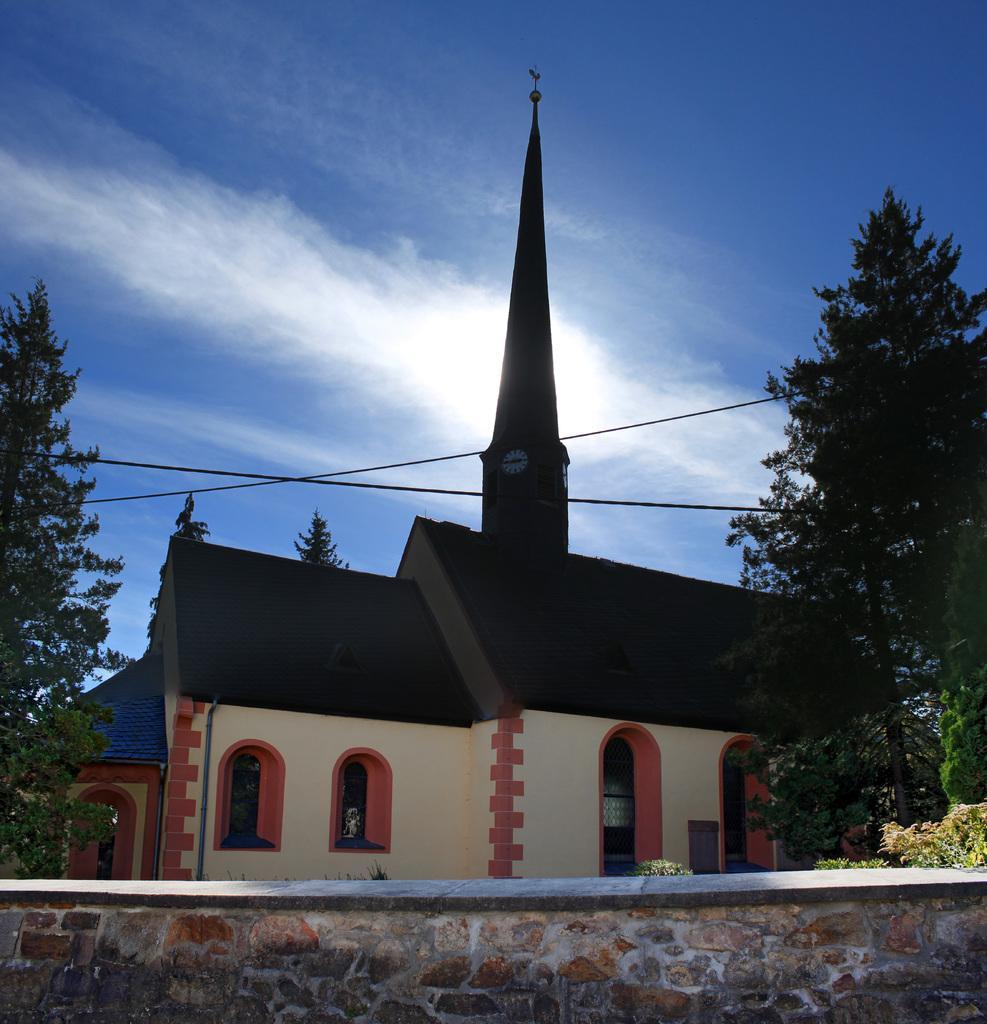Can you describe this image briefly? In this image we can see there is a clock attached to the building. In front of the building there are trees, wall, rope and the sky. 